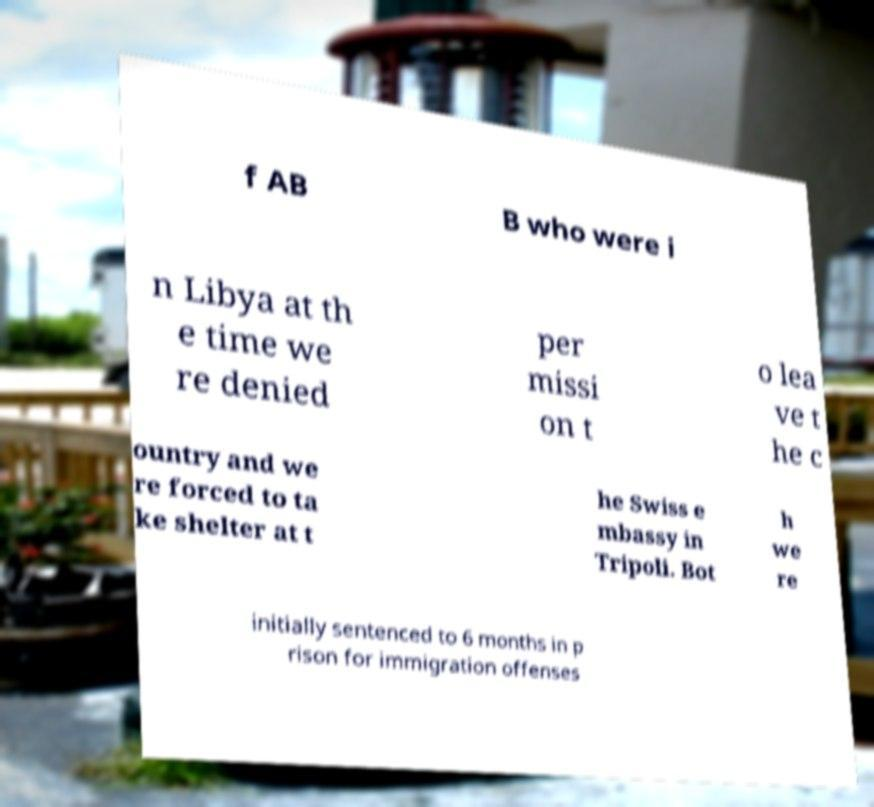Please read and relay the text visible in this image. What does it say? f AB B who were i n Libya at th e time we re denied per missi on t o lea ve t he c ountry and we re forced to ta ke shelter at t he Swiss e mbassy in Tripoli. Bot h we re initially sentenced to 6 months in p rison for immigration offenses 